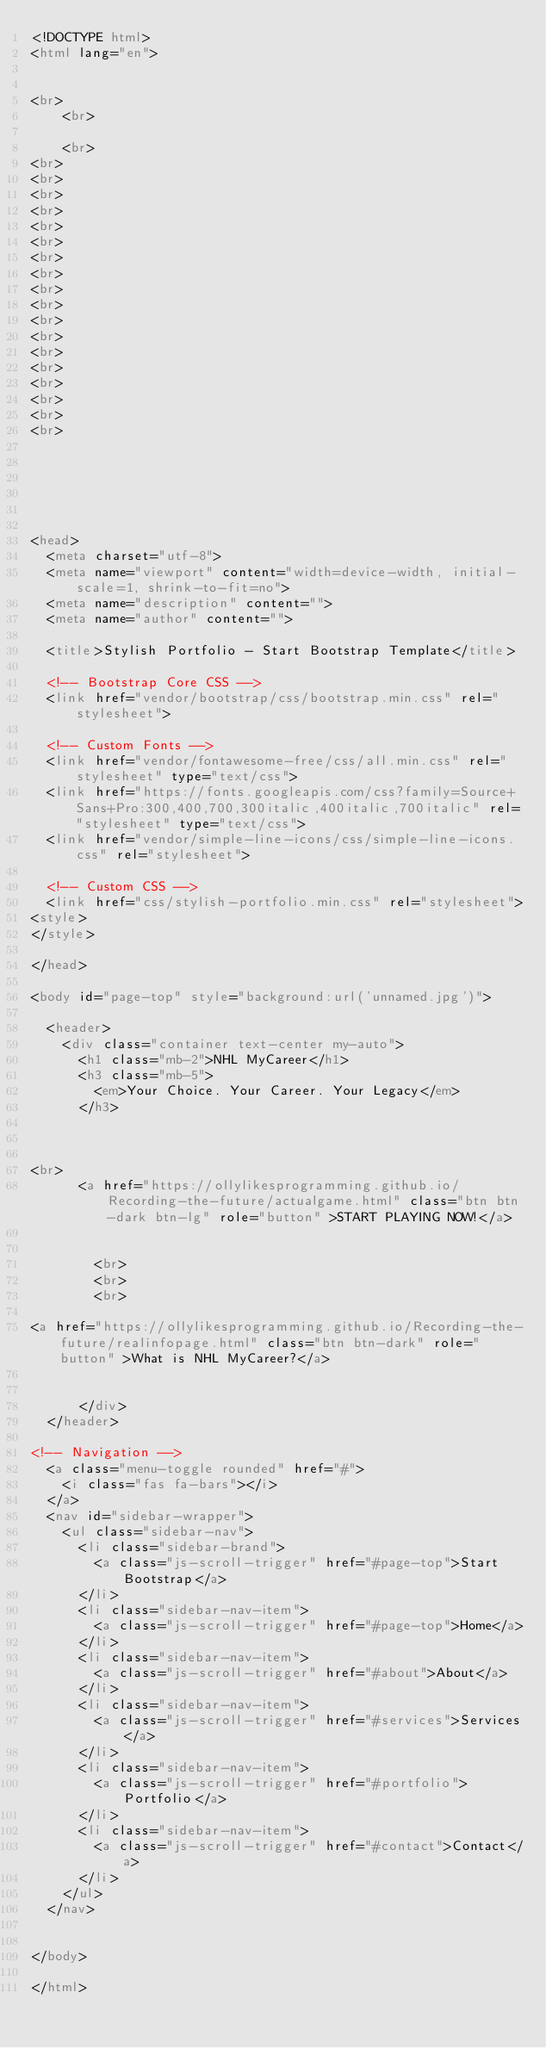<code> <loc_0><loc_0><loc_500><loc_500><_HTML_><!DOCTYPE html>
<html lang="en">

    
<br>
    <br>

    <br>
<br>
<br>
<br>
<br>
<br>
<br>
<br>
<br>
<br>
<br>
<br>
<br>
<br>
<br>
<br>
<br>
<br>
<br>


    
    
    
    
<head>
  <meta charset="utf-8">
  <meta name="viewport" content="width=device-width, initial-scale=1, shrink-to-fit=no">
  <meta name="description" content="">
  <meta name="author" content="">

  <title>Stylish Portfolio - Start Bootstrap Template</title>

  <!-- Bootstrap Core CSS -->
  <link href="vendor/bootstrap/css/bootstrap.min.css" rel="stylesheet">

  <!-- Custom Fonts -->
  <link href="vendor/fontawesome-free/css/all.min.css" rel="stylesheet" type="text/css">
  <link href="https://fonts.googleapis.com/css?family=Source+Sans+Pro:300,400,700,300italic,400italic,700italic" rel="stylesheet" type="text/css">
  <link href="vendor/simple-line-icons/css/simple-line-icons.css" rel="stylesheet">

  <!-- Custom CSS -->
  <link href="css/stylish-portfolio.min.css" rel="stylesheet">
<style>
</style>

</head>

<body id="page-top" style="background:url('unnamed.jpg')">

  <header>
    <div class="container text-center my-auto">
      <h1 class="mb-2">NHL MyCareer</h1>
      <h3 class="mb-5">
        <em>Your Choice. Your Career. Your Legacy</em>
      </h3>



<br>
      <a href="https://ollylikesprogramming.github.io/Recording-the-future/actualgame.html" class="btn btn-dark btn-lg" role="button" >START PLAYING NOW!</a>

        
        <br>
        <br>
        <br>
        
<a href="https://ollylikesprogramming.github.io/Recording-the-future/realinfopage.html" class="btn btn-dark" role="button" >What is NHL MyCareer?</a>


      </div>
  </header>
    
<!-- Navigation -->
  <a class="menu-toggle rounded" href="#">
    <i class="fas fa-bars"></i>
  </a>
  <nav id="sidebar-wrapper">
    <ul class="sidebar-nav">
      <li class="sidebar-brand">
        <a class="js-scroll-trigger" href="#page-top">Start Bootstrap</a>
      </li>
      <li class="sidebar-nav-item">
        <a class="js-scroll-trigger" href="#page-top">Home</a>
      </li>
      <li class="sidebar-nav-item">
        <a class="js-scroll-trigger" href="#about">About</a>
      </li>
      <li class="sidebar-nav-item">
        <a class="js-scroll-trigger" href="#services">Services</a>
      </li>
      <li class="sidebar-nav-item">
        <a class="js-scroll-trigger" href="#portfolio">Portfolio</a>
      </li>
      <li class="sidebar-nav-item">
        <a class="js-scroll-trigger" href="#contact">Contact</a>
      </li>
    </ul>
  </nav>


</body>

</html>
</code> 